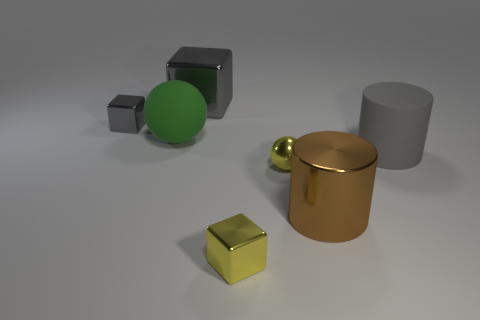There is a metal thing that is the same shape as the big green rubber thing; what is its color?
Your response must be concise. Yellow. What number of green objects have the same shape as the small gray shiny thing?
Your answer should be very brief. 0. There is a large object that is the same color as the large block; what is it made of?
Keep it short and to the point. Rubber. How many small objects are there?
Provide a short and direct response. 3. Is there a big brown cylinder made of the same material as the tiny gray block?
Your response must be concise. Yes. There is another block that is the same color as the large block; what is its size?
Your response must be concise. Small. There is a gray thing behind the small gray block; is it the same size as the gray thing that is to the left of the large green thing?
Offer a terse response. No. There is a rubber object on the left side of the metallic cylinder; how big is it?
Make the answer very short. Large. Is there a metal block that has the same color as the tiny shiny ball?
Ensure brevity in your answer.  Yes. Are there any yellow blocks that are in front of the big shiny thing in front of the small gray metallic block?
Provide a short and direct response. Yes. 